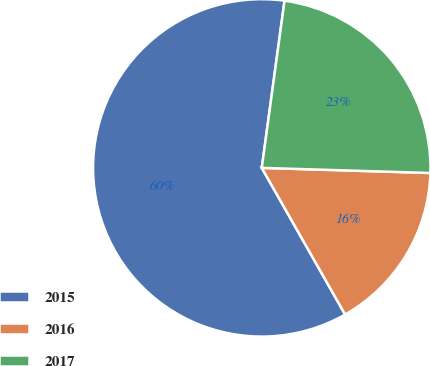Convert chart. <chart><loc_0><loc_0><loc_500><loc_500><pie_chart><fcel>2015<fcel>2016<fcel>2017<nl><fcel>60.38%<fcel>16.29%<fcel>23.33%<nl></chart> 